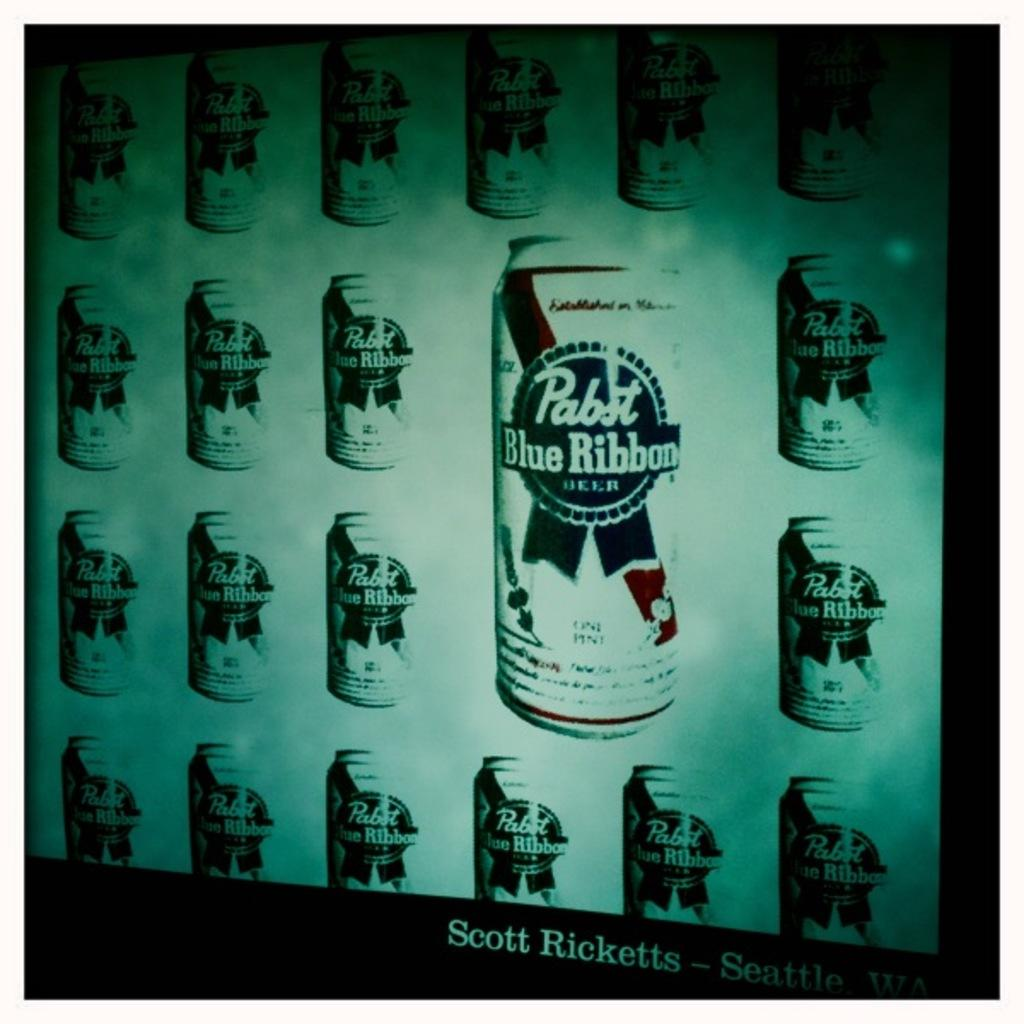<image>
Describe the image concisely. A series of Pabst Blue Ribbon cans are displayed on a wall. 